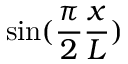Convert formula to latex. <formula><loc_0><loc_0><loc_500><loc_500>\sin ( \frac { \pi } { 2 } \frac { x } { L } )</formula> 